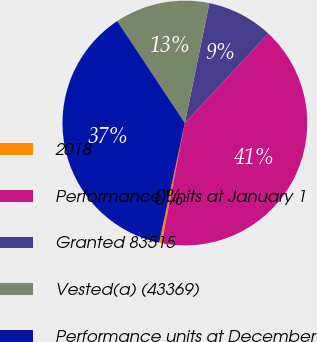Convert chart. <chart><loc_0><loc_0><loc_500><loc_500><pie_chart><fcel>2018<fcel>Performance units at January 1<fcel>Granted 83515<fcel>Vested(a) (43369)<fcel>Performance units at December<nl><fcel>0.33%<fcel>41.1%<fcel>8.74%<fcel>12.53%<fcel>37.31%<nl></chart> 